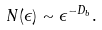<formula> <loc_0><loc_0><loc_500><loc_500>N ( \epsilon ) \sim \epsilon ^ { - D _ { b } } .</formula> 